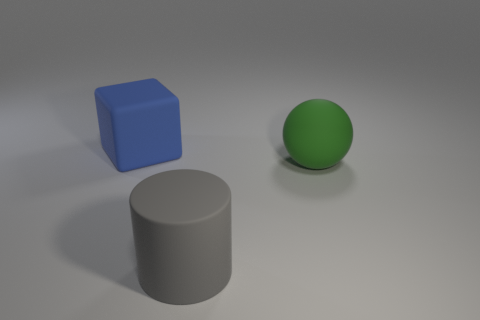Add 2 rubber things. How many objects exist? 5 Subtract all balls. How many objects are left? 2 Subtract all tiny metal things. Subtract all cylinders. How many objects are left? 2 Add 3 balls. How many balls are left? 4 Add 2 blue metal things. How many blue metal things exist? 2 Subtract 0 yellow cylinders. How many objects are left? 3 